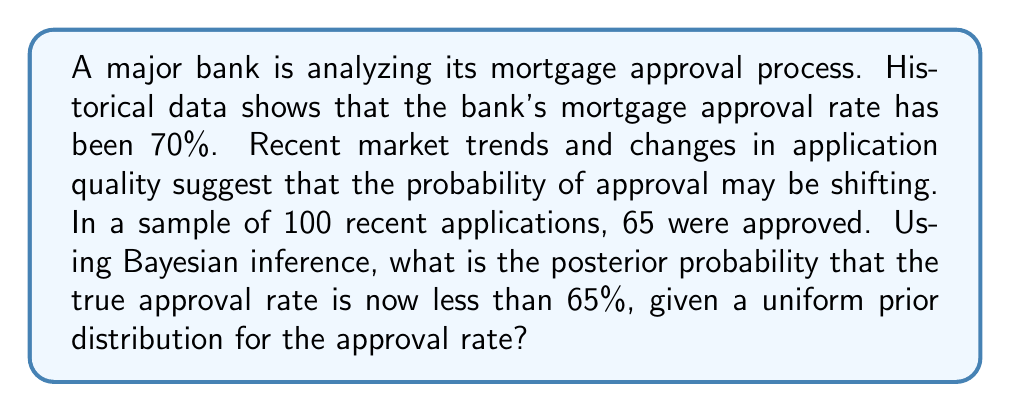Solve this math problem. To solve this problem using Bayesian inference, we'll follow these steps:

1) Define our prior distribution:
   We're given a uniform prior distribution for the approval rate, which means we assume all rates between 0 and 1 are equally likely before seeing the new data.

2) Define our likelihood function:
   The likelihood function is binomial, as each application is either approved or not.

3) Calculate the posterior distribution:
   The posterior distribution is proportional to the product of the prior and the likelihood.

4) Integrate the posterior distribution from 0 to 0.65 to find the probability that the true rate is less than 65%.

Let $\theta$ be the true approval rate.

The likelihood function is:

$$ L(\theta | x) = \binom{n}{x} \theta^x (1-\theta)^{n-x} $$

Where $n = 100$ (total applications) and $x = 65$ (approved applications).

The posterior distribution is proportional to:

$$ p(\theta | x) \propto \theta^{65} (1-\theta)^{35} $$

This is a Beta(66, 36) distribution.

To find the probability that $\theta < 0.65$, we need to calculate:

$$ P(\theta < 0.65 | x) = \int_0^{0.65} \frac{\theta^{65} (1-\theta)^{35}}{B(66, 36)} d\theta $$

Where $B(66, 36)$ is the Beta function, which normalizes the distribution.

This integral doesn't have a simple closed form, so we typically use numerical methods or statistical software to evaluate it. Using such methods, we find:

$$ P(\theta < 0.65 | x) \approx 0.1648 $$
Answer: The posterior probability that the true approval rate is now less than 65% is approximately 0.1648 or 16.48%. 